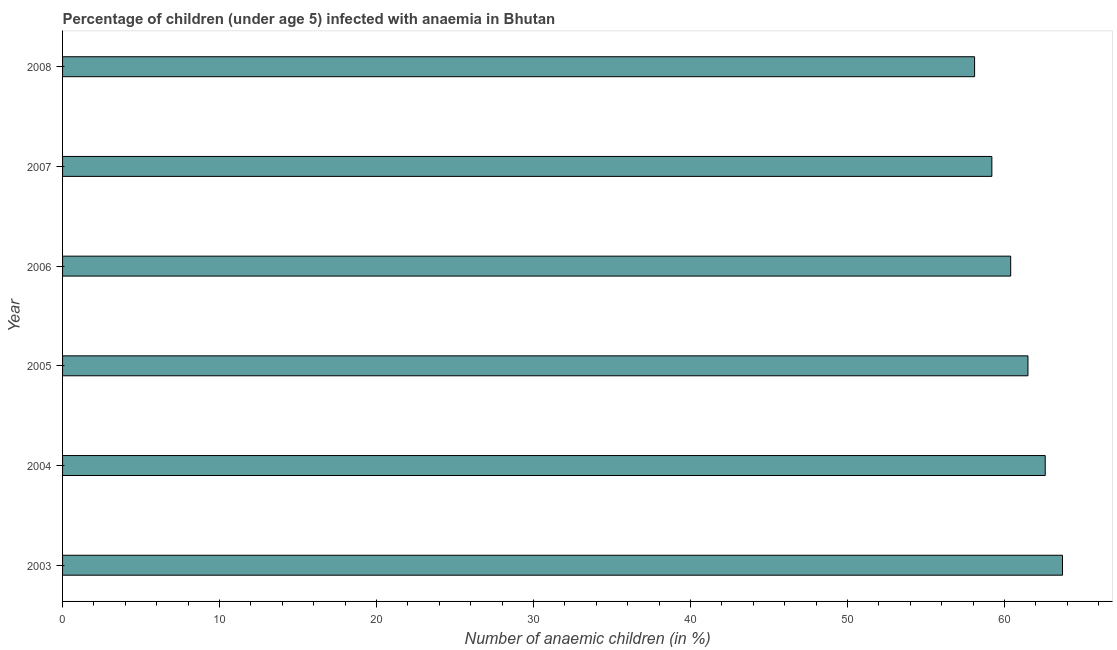Does the graph contain any zero values?
Provide a short and direct response. No. What is the title of the graph?
Your answer should be very brief. Percentage of children (under age 5) infected with anaemia in Bhutan. What is the label or title of the X-axis?
Offer a terse response. Number of anaemic children (in %). What is the number of anaemic children in 2006?
Provide a short and direct response. 60.4. Across all years, what is the maximum number of anaemic children?
Provide a succinct answer. 63.7. Across all years, what is the minimum number of anaemic children?
Provide a succinct answer. 58.1. What is the sum of the number of anaemic children?
Your answer should be very brief. 365.5. What is the average number of anaemic children per year?
Provide a succinct answer. 60.92. What is the median number of anaemic children?
Keep it short and to the point. 60.95. In how many years, is the number of anaemic children greater than 32 %?
Offer a very short reply. 6. Do a majority of the years between 2006 and 2004 (inclusive) have number of anaemic children greater than 18 %?
Provide a short and direct response. Yes. What is the ratio of the number of anaemic children in 2004 to that in 2005?
Offer a very short reply. 1.02. Is the difference between the number of anaemic children in 2006 and 2008 greater than the difference between any two years?
Your answer should be compact. No. How many bars are there?
Your response must be concise. 6. Are all the bars in the graph horizontal?
Keep it short and to the point. Yes. What is the difference between two consecutive major ticks on the X-axis?
Give a very brief answer. 10. What is the Number of anaemic children (in %) in 2003?
Provide a short and direct response. 63.7. What is the Number of anaemic children (in %) of 2004?
Provide a short and direct response. 62.6. What is the Number of anaemic children (in %) in 2005?
Your response must be concise. 61.5. What is the Number of anaemic children (in %) in 2006?
Offer a terse response. 60.4. What is the Number of anaemic children (in %) of 2007?
Offer a very short reply. 59.2. What is the Number of anaemic children (in %) in 2008?
Your response must be concise. 58.1. What is the difference between the Number of anaemic children (in %) in 2003 and 2004?
Your response must be concise. 1.1. What is the difference between the Number of anaemic children (in %) in 2003 and 2005?
Offer a very short reply. 2.2. What is the difference between the Number of anaemic children (in %) in 2003 and 2007?
Give a very brief answer. 4.5. What is the difference between the Number of anaemic children (in %) in 2005 and 2006?
Offer a terse response. 1.1. What is the difference between the Number of anaemic children (in %) in 2005 and 2007?
Make the answer very short. 2.3. What is the difference between the Number of anaemic children (in %) in 2005 and 2008?
Ensure brevity in your answer.  3.4. What is the difference between the Number of anaemic children (in %) in 2006 and 2008?
Your answer should be very brief. 2.3. What is the difference between the Number of anaemic children (in %) in 2007 and 2008?
Your response must be concise. 1.1. What is the ratio of the Number of anaemic children (in %) in 2003 to that in 2004?
Your answer should be very brief. 1.02. What is the ratio of the Number of anaemic children (in %) in 2003 to that in 2005?
Give a very brief answer. 1.04. What is the ratio of the Number of anaemic children (in %) in 2003 to that in 2006?
Offer a terse response. 1.05. What is the ratio of the Number of anaemic children (in %) in 2003 to that in 2007?
Provide a succinct answer. 1.08. What is the ratio of the Number of anaemic children (in %) in 2003 to that in 2008?
Keep it short and to the point. 1.1. What is the ratio of the Number of anaemic children (in %) in 2004 to that in 2005?
Offer a terse response. 1.02. What is the ratio of the Number of anaemic children (in %) in 2004 to that in 2006?
Ensure brevity in your answer.  1.04. What is the ratio of the Number of anaemic children (in %) in 2004 to that in 2007?
Give a very brief answer. 1.06. What is the ratio of the Number of anaemic children (in %) in 2004 to that in 2008?
Offer a terse response. 1.08. What is the ratio of the Number of anaemic children (in %) in 2005 to that in 2006?
Keep it short and to the point. 1.02. What is the ratio of the Number of anaemic children (in %) in 2005 to that in 2007?
Ensure brevity in your answer.  1.04. What is the ratio of the Number of anaemic children (in %) in 2005 to that in 2008?
Make the answer very short. 1.06. What is the ratio of the Number of anaemic children (in %) in 2006 to that in 2007?
Provide a succinct answer. 1.02. What is the ratio of the Number of anaemic children (in %) in 2006 to that in 2008?
Your answer should be compact. 1.04. 